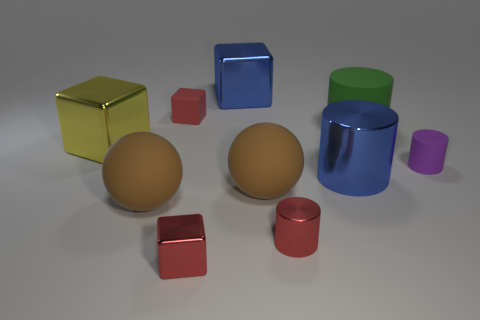There is a red cylinder that is the same size as the purple object; what is its material?
Your answer should be very brief. Metal. Is the number of purple matte cylinders greater than the number of big gray cylinders?
Give a very brief answer. Yes. There is a rubber object behind the matte cylinder that is to the left of the purple cylinder; what is its size?
Offer a very short reply. Small. What is the shape of the purple thing that is the same size as the red rubber cube?
Offer a terse response. Cylinder. There is a rubber thing to the right of the large rubber object behind the shiny cylinder that is to the right of the tiny red cylinder; what is its shape?
Give a very brief answer. Cylinder. Does the big metallic thing that is on the right side of the small red shiny cylinder have the same color as the big metallic block that is behind the red rubber cube?
Offer a terse response. Yes. How many tiny red metallic things are there?
Your response must be concise. 2. There is a tiny matte block; are there any matte balls on the right side of it?
Make the answer very short. Yes. Does the large blue thing that is left of the blue metal cylinder have the same material as the large sphere left of the tiny red rubber block?
Provide a short and direct response. No. Is the number of large objects that are in front of the large green object less than the number of blue shiny cylinders?
Offer a very short reply. No. 